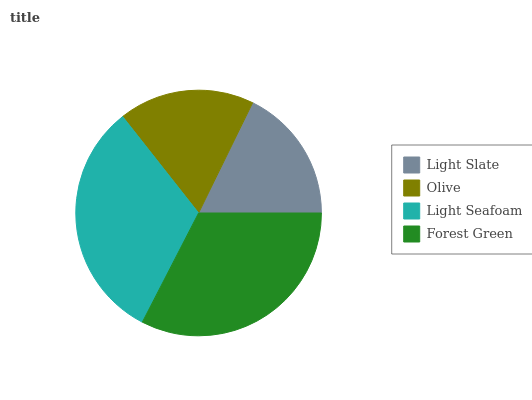Is Light Slate the minimum?
Answer yes or no. Yes. Is Forest Green the maximum?
Answer yes or no. Yes. Is Olive the minimum?
Answer yes or no. No. Is Olive the maximum?
Answer yes or no. No. Is Olive greater than Light Slate?
Answer yes or no. Yes. Is Light Slate less than Olive?
Answer yes or no. Yes. Is Light Slate greater than Olive?
Answer yes or no. No. Is Olive less than Light Slate?
Answer yes or no. No. Is Light Seafoam the high median?
Answer yes or no. Yes. Is Olive the low median?
Answer yes or no. Yes. Is Light Slate the high median?
Answer yes or no. No. Is Light Seafoam the low median?
Answer yes or no. No. 